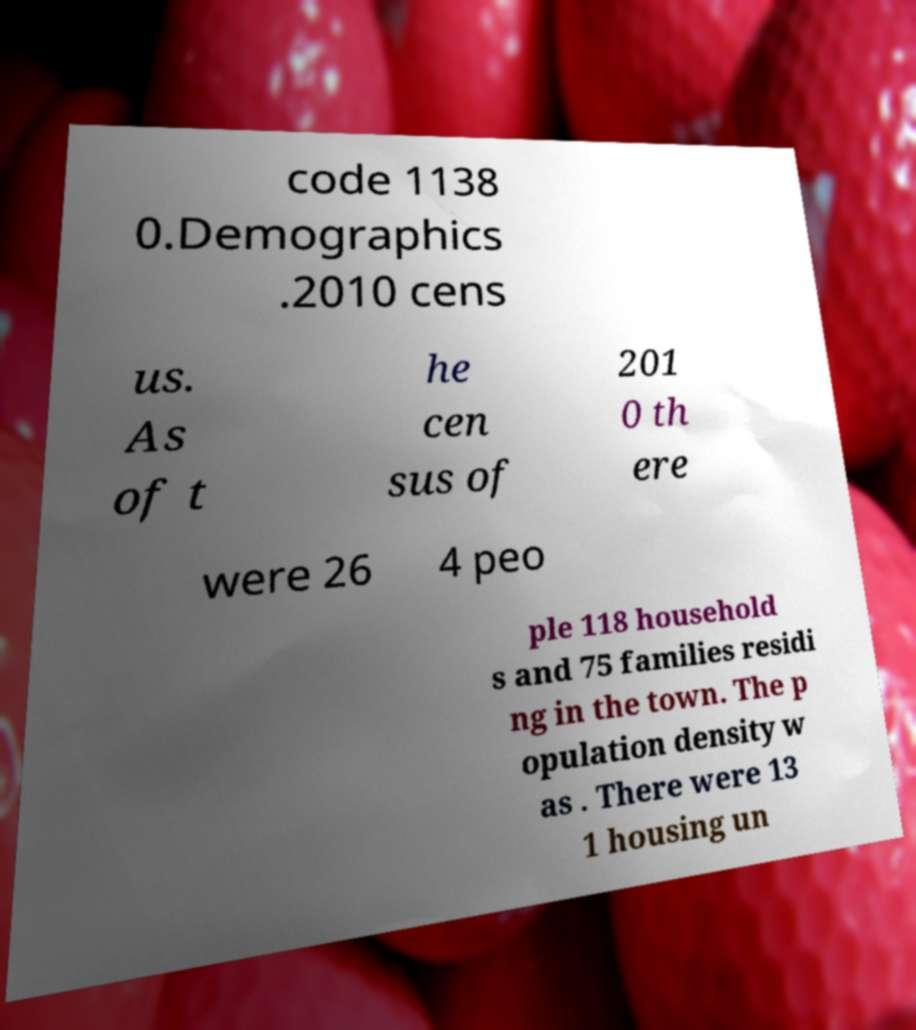Please identify and transcribe the text found in this image. code 1138 0.Demographics .2010 cens us. As of t he cen sus of 201 0 th ere were 26 4 peo ple 118 household s and 75 families residi ng in the town. The p opulation density w as . There were 13 1 housing un 